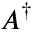<formula> <loc_0><loc_0><loc_500><loc_500>A ^ { \dagger }</formula> 